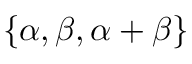Convert formula to latex. <formula><loc_0><loc_0><loc_500><loc_500>\{ \alpha , \beta , \alpha + \beta \}</formula> 